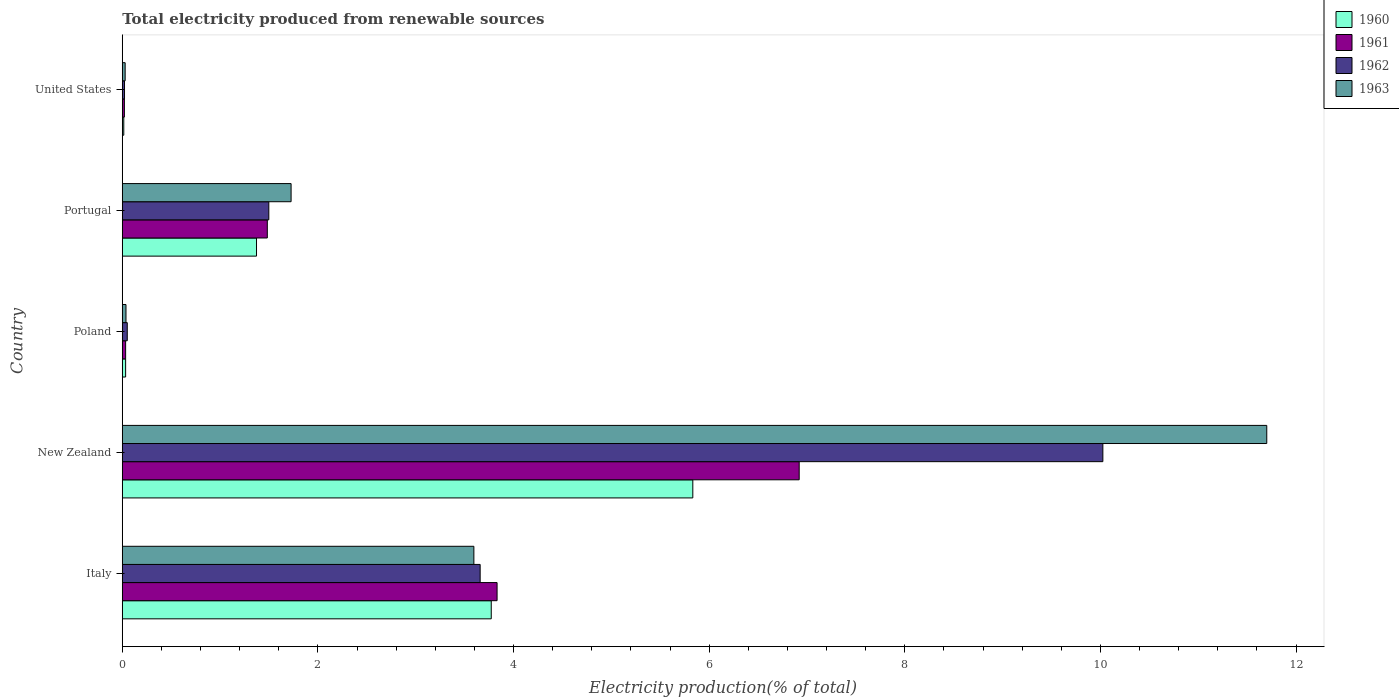How many groups of bars are there?
Provide a succinct answer. 5. Are the number of bars on each tick of the Y-axis equal?
Provide a succinct answer. Yes. How many bars are there on the 1st tick from the top?
Your answer should be compact. 4. How many bars are there on the 2nd tick from the bottom?
Ensure brevity in your answer.  4. What is the label of the 2nd group of bars from the top?
Ensure brevity in your answer.  Portugal. What is the total electricity produced in 1960 in Portugal?
Provide a succinct answer. 1.37. Across all countries, what is the maximum total electricity produced in 1960?
Make the answer very short. 5.83. Across all countries, what is the minimum total electricity produced in 1963?
Your answer should be compact. 0.03. In which country was the total electricity produced in 1960 maximum?
Provide a succinct answer. New Zealand. What is the total total electricity produced in 1963 in the graph?
Keep it short and to the point. 17.09. What is the difference between the total electricity produced in 1962 in Italy and that in New Zealand?
Your response must be concise. -6.37. What is the difference between the total electricity produced in 1961 in United States and the total electricity produced in 1960 in New Zealand?
Provide a short and direct response. -5.81. What is the average total electricity produced in 1962 per country?
Your answer should be very brief. 3.05. What is the difference between the total electricity produced in 1961 and total electricity produced in 1960 in Portugal?
Offer a very short reply. 0.11. What is the ratio of the total electricity produced in 1960 in Portugal to that in United States?
Your answer should be very brief. 89.96. What is the difference between the highest and the second highest total electricity produced in 1960?
Make the answer very short. 2.06. What is the difference between the highest and the lowest total electricity produced in 1963?
Offer a very short reply. 11.67. In how many countries, is the total electricity produced in 1962 greater than the average total electricity produced in 1962 taken over all countries?
Offer a very short reply. 2. Is the sum of the total electricity produced in 1962 in Italy and United States greater than the maximum total electricity produced in 1963 across all countries?
Offer a terse response. No. Is it the case that in every country, the sum of the total electricity produced in 1963 and total electricity produced in 1960 is greater than the sum of total electricity produced in 1962 and total electricity produced in 1961?
Provide a succinct answer. No. What does the 4th bar from the top in Italy represents?
Your response must be concise. 1960. What does the 1st bar from the bottom in Italy represents?
Your response must be concise. 1960. How many bars are there?
Your response must be concise. 20. Are all the bars in the graph horizontal?
Make the answer very short. Yes. Are the values on the major ticks of X-axis written in scientific E-notation?
Your response must be concise. No. Does the graph contain any zero values?
Offer a terse response. No. How are the legend labels stacked?
Your response must be concise. Vertical. What is the title of the graph?
Provide a short and direct response. Total electricity produced from renewable sources. Does "1961" appear as one of the legend labels in the graph?
Keep it short and to the point. Yes. What is the label or title of the Y-axis?
Ensure brevity in your answer.  Country. What is the Electricity production(% of total) of 1960 in Italy?
Provide a succinct answer. 3.77. What is the Electricity production(% of total) of 1961 in Italy?
Give a very brief answer. 3.83. What is the Electricity production(% of total) in 1962 in Italy?
Your response must be concise. 3.66. What is the Electricity production(% of total) in 1963 in Italy?
Ensure brevity in your answer.  3.59. What is the Electricity production(% of total) in 1960 in New Zealand?
Keep it short and to the point. 5.83. What is the Electricity production(% of total) in 1961 in New Zealand?
Keep it short and to the point. 6.92. What is the Electricity production(% of total) of 1962 in New Zealand?
Your answer should be very brief. 10.02. What is the Electricity production(% of total) of 1963 in New Zealand?
Ensure brevity in your answer.  11.7. What is the Electricity production(% of total) in 1960 in Poland?
Provide a succinct answer. 0.03. What is the Electricity production(% of total) in 1961 in Poland?
Your answer should be very brief. 0.03. What is the Electricity production(% of total) of 1962 in Poland?
Offer a very short reply. 0.05. What is the Electricity production(% of total) of 1963 in Poland?
Your answer should be very brief. 0.04. What is the Electricity production(% of total) of 1960 in Portugal?
Offer a very short reply. 1.37. What is the Electricity production(% of total) of 1961 in Portugal?
Ensure brevity in your answer.  1.48. What is the Electricity production(% of total) in 1962 in Portugal?
Provide a short and direct response. 1.5. What is the Electricity production(% of total) in 1963 in Portugal?
Offer a terse response. 1.73. What is the Electricity production(% of total) in 1960 in United States?
Ensure brevity in your answer.  0.02. What is the Electricity production(% of total) in 1961 in United States?
Provide a short and direct response. 0.02. What is the Electricity production(% of total) in 1962 in United States?
Provide a short and direct response. 0.02. What is the Electricity production(% of total) of 1963 in United States?
Ensure brevity in your answer.  0.03. Across all countries, what is the maximum Electricity production(% of total) of 1960?
Provide a succinct answer. 5.83. Across all countries, what is the maximum Electricity production(% of total) in 1961?
Offer a terse response. 6.92. Across all countries, what is the maximum Electricity production(% of total) in 1962?
Make the answer very short. 10.02. Across all countries, what is the maximum Electricity production(% of total) of 1963?
Keep it short and to the point. 11.7. Across all countries, what is the minimum Electricity production(% of total) in 1960?
Ensure brevity in your answer.  0.02. Across all countries, what is the minimum Electricity production(% of total) in 1961?
Your response must be concise. 0.02. Across all countries, what is the minimum Electricity production(% of total) in 1962?
Keep it short and to the point. 0.02. Across all countries, what is the minimum Electricity production(% of total) of 1963?
Provide a short and direct response. 0.03. What is the total Electricity production(% of total) of 1960 in the graph?
Provide a succinct answer. 11.03. What is the total Electricity production(% of total) in 1961 in the graph?
Your answer should be very brief. 12.29. What is the total Electricity production(% of total) of 1962 in the graph?
Offer a very short reply. 15.25. What is the total Electricity production(% of total) in 1963 in the graph?
Offer a very short reply. 17.09. What is the difference between the Electricity production(% of total) of 1960 in Italy and that in New Zealand?
Provide a short and direct response. -2.06. What is the difference between the Electricity production(% of total) in 1961 in Italy and that in New Zealand?
Offer a very short reply. -3.09. What is the difference between the Electricity production(% of total) in 1962 in Italy and that in New Zealand?
Provide a succinct answer. -6.37. What is the difference between the Electricity production(% of total) in 1963 in Italy and that in New Zealand?
Your response must be concise. -8.11. What is the difference between the Electricity production(% of total) in 1960 in Italy and that in Poland?
Your answer should be very brief. 3.74. What is the difference between the Electricity production(% of total) in 1961 in Italy and that in Poland?
Provide a short and direct response. 3.8. What is the difference between the Electricity production(% of total) of 1962 in Italy and that in Poland?
Your answer should be compact. 3.61. What is the difference between the Electricity production(% of total) in 1963 in Italy and that in Poland?
Your response must be concise. 3.56. What is the difference between the Electricity production(% of total) of 1960 in Italy and that in Portugal?
Make the answer very short. 2.4. What is the difference between the Electricity production(% of total) of 1961 in Italy and that in Portugal?
Give a very brief answer. 2.35. What is the difference between the Electricity production(% of total) of 1962 in Italy and that in Portugal?
Your answer should be very brief. 2.16. What is the difference between the Electricity production(% of total) of 1963 in Italy and that in Portugal?
Give a very brief answer. 1.87. What is the difference between the Electricity production(% of total) in 1960 in Italy and that in United States?
Offer a terse response. 3.76. What is the difference between the Electricity production(% of total) of 1961 in Italy and that in United States?
Make the answer very short. 3.81. What is the difference between the Electricity production(% of total) in 1962 in Italy and that in United States?
Offer a terse response. 3.64. What is the difference between the Electricity production(% of total) in 1963 in Italy and that in United States?
Ensure brevity in your answer.  3.56. What is the difference between the Electricity production(% of total) of 1960 in New Zealand and that in Poland?
Your answer should be very brief. 5.8. What is the difference between the Electricity production(% of total) of 1961 in New Zealand and that in Poland?
Offer a terse response. 6.89. What is the difference between the Electricity production(% of total) of 1962 in New Zealand and that in Poland?
Offer a terse response. 9.97. What is the difference between the Electricity production(% of total) of 1963 in New Zealand and that in Poland?
Offer a terse response. 11.66. What is the difference between the Electricity production(% of total) in 1960 in New Zealand and that in Portugal?
Keep it short and to the point. 4.46. What is the difference between the Electricity production(% of total) of 1961 in New Zealand and that in Portugal?
Your answer should be compact. 5.44. What is the difference between the Electricity production(% of total) of 1962 in New Zealand and that in Portugal?
Provide a succinct answer. 8.53. What is the difference between the Electricity production(% of total) of 1963 in New Zealand and that in Portugal?
Ensure brevity in your answer.  9.97. What is the difference between the Electricity production(% of total) of 1960 in New Zealand and that in United States?
Keep it short and to the point. 5.82. What is the difference between the Electricity production(% of total) of 1961 in New Zealand and that in United States?
Offer a very short reply. 6.9. What is the difference between the Electricity production(% of total) in 1962 in New Zealand and that in United States?
Provide a short and direct response. 10. What is the difference between the Electricity production(% of total) of 1963 in New Zealand and that in United States?
Offer a very short reply. 11.67. What is the difference between the Electricity production(% of total) of 1960 in Poland and that in Portugal?
Keep it short and to the point. -1.34. What is the difference between the Electricity production(% of total) of 1961 in Poland and that in Portugal?
Provide a succinct answer. -1.45. What is the difference between the Electricity production(% of total) in 1962 in Poland and that in Portugal?
Make the answer very short. -1.45. What is the difference between the Electricity production(% of total) of 1963 in Poland and that in Portugal?
Ensure brevity in your answer.  -1.69. What is the difference between the Electricity production(% of total) in 1960 in Poland and that in United States?
Your answer should be very brief. 0.02. What is the difference between the Electricity production(% of total) in 1961 in Poland and that in United States?
Ensure brevity in your answer.  0.01. What is the difference between the Electricity production(% of total) in 1962 in Poland and that in United States?
Offer a terse response. 0.03. What is the difference between the Electricity production(% of total) in 1963 in Poland and that in United States?
Ensure brevity in your answer.  0.01. What is the difference between the Electricity production(% of total) of 1960 in Portugal and that in United States?
Your answer should be very brief. 1.36. What is the difference between the Electricity production(% of total) of 1961 in Portugal and that in United States?
Give a very brief answer. 1.46. What is the difference between the Electricity production(% of total) in 1962 in Portugal and that in United States?
Provide a succinct answer. 1.48. What is the difference between the Electricity production(% of total) of 1963 in Portugal and that in United States?
Your answer should be very brief. 1.7. What is the difference between the Electricity production(% of total) in 1960 in Italy and the Electricity production(% of total) in 1961 in New Zealand?
Provide a succinct answer. -3.15. What is the difference between the Electricity production(% of total) of 1960 in Italy and the Electricity production(% of total) of 1962 in New Zealand?
Provide a short and direct response. -6.25. What is the difference between the Electricity production(% of total) of 1960 in Italy and the Electricity production(% of total) of 1963 in New Zealand?
Provide a short and direct response. -7.93. What is the difference between the Electricity production(% of total) of 1961 in Italy and the Electricity production(% of total) of 1962 in New Zealand?
Offer a terse response. -6.19. What is the difference between the Electricity production(% of total) of 1961 in Italy and the Electricity production(% of total) of 1963 in New Zealand?
Ensure brevity in your answer.  -7.87. What is the difference between the Electricity production(% of total) of 1962 in Italy and the Electricity production(% of total) of 1963 in New Zealand?
Offer a terse response. -8.04. What is the difference between the Electricity production(% of total) in 1960 in Italy and the Electricity production(% of total) in 1961 in Poland?
Make the answer very short. 3.74. What is the difference between the Electricity production(% of total) of 1960 in Italy and the Electricity production(% of total) of 1962 in Poland?
Provide a succinct answer. 3.72. What is the difference between the Electricity production(% of total) in 1960 in Italy and the Electricity production(% of total) in 1963 in Poland?
Ensure brevity in your answer.  3.73. What is the difference between the Electricity production(% of total) of 1961 in Italy and the Electricity production(% of total) of 1962 in Poland?
Give a very brief answer. 3.78. What is the difference between the Electricity production(% of total) in 1961 in Italy and the Electricity production(% of total) in 1963 in Poland?
Your response must be concise. 3.79. What is the difference between the Electricity production(% of total) in 1962 in Italy and the Electricity production(% of total) in 1963 in Poland?
Provide a short and direct response. 3.62. What is the difference between the Electricity production(% of total) of 1960 in Italy and the Electricity production(% of total) of 1961 in Portugal?
Ensure brevity in your answer.  2.29. What is the difference between the Electricity production(% of total) of 1960 in Italy and the Electricity production(% of total) of 1962 in Portugal?
Your answer should be compact. 2.27. What is the difference between the Electricity production(% of total) in 1960 in Italy and the Electricity production(% of total) in 1963 in Portugal?
Make the answer very short. 2.05. What is the difference between the Electricity production(% of total) in 1961 in Italy and the Electricity production(% of total) in 1962 in Portugal?
Your answer should be very brief. 2.33. What is the difference between the Electricity production(% of total) in 1961 in Italy and the Electricity production(% of total) in 1963 in Portugal?
Provide a short and direct response. 2.11. What is the difference between the Electricity production(% of total) in 1962 in Italy and the Electricity production(% of total) in 1963 in Portugal?
Provide a succinct answer. 1.93. What is the difference between the Electricity production(% of total) of 1960 in Italy and the Electricity production(% of total) of 1961 in United States?
Provide a succinct answer. 3.75. What is the difference between the Electricity production(% of total) of 1960 in Italy and the Electricity production(% of total) of 1962 in United States?
Your answer should be compact. 3.75. What is the difference between the Electricity production(% of total) of 1960 in Italy and the Electricity production(% of total) of 1963 in United States?
Your answer should be compact. 3.74. What is the difference between the Electricity production(% of total) of 1961 in Italy and the Electricity production(% of total) of 1962 in United States?
Offer a terse response. 3.81. What is the difference between the Electricity production(% of total) of 1961 in Italy and the Electricity production(% of total) of 1963 in United States?
Provide a short and direct response. 3.8. What is the difference between the Electricity production(% of total) in 1962 in Italy and the Electricity production(% of total) in 1963 in United States?
Your answer should be compact. 3.63. What is the difference between the Electricity production(% of total) in 1960 in New Zealand and the Electricity production(% of total) in 1961 in Poland?
Keep it short and to the point. 5.8. What is the difference between the Electricity production(% of total) in 1960 in New Zealand and the Electricity production(% of total) in 1962 in Poland?
Keep it short and to the point. 5.78. What is the difference between the Electricity production(% of total) of 1960 in New Zealand and the Electricity production(% of total) of 1963 in Poland?
Offer a very short reply. 5.79. What is the difference between the Electricity production(% of total) of 1961 in New Zealand and the Electricity production(% of total) of 1962 in Poland?
Provide a short and direct response. 6.87. What is the difference between the Electricity production(% of total) of 1961 in New Zealand and the Electricity production(% of total) of 1963 in Poland?
Your answer should be compact. 6.88. What is the difference between the Electricity production(% of total) of 1962 in New Zealand and the Electricity production(% of total) of 1963 in Poland?
Make the answer very short. 9.99. What is the difference between the Electricity production(% of total) of 1960 in New Zealand and the Electricity production(% of total) of 1961 in Portugal?
Provide a short and direct response. 4.35. What is the difference between the Electricity production(% of total) of 1960 in New Zealand and the Electricity production(% of total) of 1962 in Portugal?
Your response must be concise. 4.33. What is the difference between the Electricity production(% of total) of 1960 in New Zealand and the Electricity production(% of total) of 1963 in Portugal?
Offer a very short reply. 4.11. What is the difference between the Electricity production(% of total) in 1961 in New Zealand and the Electricity production(% of total) in 1962 in Portugal?
Your answer should be very brief. 5.42. What is the difference between the Electricity production(% of total) in 1961 in New Zealand and the Electricity production(% of total) in 1963 in Portugal?
Your answer should be compact. 5.19. What is the difference between the Electricity production(% of total) of 1962 in New Zealand and the Electricity production(% of total) of 1963 in Portugal?
Provide a short and direct response. 8.3. What is the difference between the Electricity production(% of total) in 1960 in New Zealand and the Electricity production(% of total) in 1961 in United States?
Give a very brief answer. 5.81. What is the difference between the Electricity production(% of total) of 1960 in New Zealand and the Electricity production(% of total) of 1962 in United States?
Your answer should be very brief. 5.81. What is the difference between the Electricity production(% of total) of 1960 in New Zealand and the Electricity production(% of total) of 1963 in United States?
Ensure brevity in your answer.  5.8. What is the difference between the Electricity production(% of total) of 1961 in New Zealand and the Electricity production(% of total) of 1962 in United States?
Your answer should be compact. 6.9. What is the difference between the Electricity production(% of total) of 1961 in New Zealand and the Electricity production(% of total) of 1963 in United States?
Offer a terse response. 6.89. What is the difference between the Electricity production(% of total) in 1962 in New Zealand and the Electricity production(% of total) in 1963 in United States?
Offer a terse response. 10. What is the difference between the Electricity production(% of total) in 1960 in Poland and the Electricity production(% of total) in 1961 in Portugal?
Offer a terse response. -1.45. What is the difference between the Electricity production(% of total) of 1960 in Poland and the Electricity production(% of total) of 1962 in Portugal?
Your answer should be very brief. -1.46. What is the difference between the Electricity production(% of total) in 1960 in Poland and the Electricity production(% of total) in 1963 in Portugal?
Ensure brevity in your answer.  -1.69. What is the difference between the Electricity production(% of total) of 1961 in Poland and the Electricity production(% of total) of 1962 in Portugal?
Provide a short and direct response. -1.46. What is the difference between the Electricity production(% of total) of 1961 in Poland and the Electricity production(% of total) of 1963 in Portugal?
Your answer should be very brief. -1.69. What is the difference between the Electricity production(% of total) in 1962 in Poland and the Electricity production(% of total) in 1963 in Portugal?
Keep it short and to the point. -1.67. What is the difference between the Electricity production(% of total) in 1960 in Poland and the Electricity production(% of total) in 1961 in United States?
Your response must be concise. 0.01. What is the difference between the Electricity production(% of total) of 1960 in Poland and the Electricity production(% of total) of 1962 in United States?
Keep it short and to the point. 0.01. What is the difference between the Electricity production(% of total) in 1960 in Poland and the Electricity production(% of total) in 1963 in United States?
Keep it short and to the point. 0. What is the difference between the Electricity production(% of total) of 1961 in Poland and the Electricity production(% of total) of 1962 in United States?
Give a very brief answer. 0.01. What is the difference between the Electricity production(% of total) in 1961 in Poland and the Electricity production(% of total) in 1963 in United States?
Offer a very short reply. 0. What is the difference between the Electricity production(% of total) in 1962 in Poland and the Electricity production(% of total) in 1963 in United States?
Make the answer very short. 0.02. What is the difference between the Electricity production(% of total) in 1960 in Portugal and the Electricity production(% of total) in 1961 in United States?
Provide a short and direct response. 1.35. What is the difference between the Electricity production(% of total) in 1960 in Portugal and the Electricity production(% of total) in 1962 in United States?
Offer a very short reply. 1.35. What is the difference between the Electricity production(% of total) of 1960 in Portugal and the Electricity production(% of total) of 1963 in United States?
Make the answer very short. 1.34. What is the difference between the Electricity production(% of total) in 1961 in Portugal and the Electricity production(% of total) in 1962 in United States?
Your response must be concise. 1.46. What is the difference between the Electricity production(% of total) of 1961 in Portugal and the Electricity production(% of total) of 1963 in United States?
Offer a terse response. 1.45. What is the difference between the Electricity production(% of total) in 1962 in Portugal and the Electricity production(% of total) in 1963 in United States?
Your response must be concise. 1.47. What is the average Electricity production(% of total) of 1960 per country?
Make the answer very short. 2.21. What is the average Electricity production(% of total) of 1961 per country?
Offer a terse response. 2.46. What is the average Electricity production(% of total) of 1962 per country?
Your answer should be compact. 3.05. What is the average Electricity production(% of total) in 1963 per country?
Provide a short and direct response. 3.42. What is the difference between the Electricity production(% of total) in 1960 and Electricity production(% of total) in 1961 in Italy?
Keep it short and to the point. -0.06. What is the difference between the Electricity production(% of total) in 1960 and Electricity production(% of total) in 1962 in Italy?
Your answer should be very brief. 0.11. What is the difference between the Electricity production(% of total) in 1960 and Electricity production(% of total) in 1963 in Italy?
Provide a short and direct response. 0.18. What is the difference between the Electricity production(% of total) in 1961 and Electricity production(% of total) in 1962 in Italy?
Give a very brief answer. 0.17. What is the difference between the Electricity production(% of total) of 1961 and Electricity production(% of total) of 1963 in Italy?
Your response must be concise. 0.24. What is the difference between the Electricity production(% of total) of 1962 and Electricity production(% of total) of 1963 in Italy?
Keep it short and to the point. 0.06. What is the difference between the Electricity production(% of total) of 1960 and Electricity production(% of total) of 1961 in New Zealand?
Offer a terse response. -1.09. What is the difference between the Electricity production(% of total) in 1960 and Electricity production(% of total) in 1962 in New Zealand?
Provide a short and direct response. -4.19. What is the difference between the Electricity production(% of total) in 1960 and Electricity production(% of total) in 1963 in New Zealand?
Your answer should be compact. -5.87. What is the difference between the Electricity production(% of total) in 1961 and Electricity production(% of total) in 1962 in New Zealand?
Your answer should be compact. -3.1. What is the difference between the Electricity production(% of total) in 1961 and Electricity production(% of total) in 1963 in New Zealand?
Make the answer very short. -4.78. What is the difference between the Electricity production(% of total) of 1962 and Electricity production(% of total) of 1963 in New Zealand?
Your response must be concise. -1.68. What is the difference between the Electricity production(% of total) of 1960 and Electricity production(% of total) of 1962 in Poland?
Provide a succinct answer. -0.02. What is the difference between the Electricity production(% of total) of 1960 and Electricity production(% of total) of 1963 in Poland?
Your response must be concise. -0. What is the difference between the Electricity production(% of total) in 1961 and Electricity production(% of total) in 1962 in Poland?
Keep it short and to the point. -0.02. What is the difference between the Electricity production(% of total) of 1961 and Electricity production(% of total) of 1963 in Poland?
Offer a very short reply. -0. What is the difference between the Electricity production(% of total) in 1962 and Electricity production(% of total) in 1963 in Poland?
Ensure brevity in your answer.  0.01. What is the difference between the Electricity production(% of total) of 1960 and Electricity production(% of total) of 1961 in Portugal?
Keep it short and to the point. -0.11. What is the difference between the Electricity production(% of total) of 1960 and Electricity production(% of total) of 1962 in Portugal?
Provide a short and direct response. -0.13. What is the difference between the Electricity production(% of total) of 1960 and Electricity production(% of total) of 1963 in Portugal?
Provide a short and direct response. -0.35. What is the difference between the Electricity production(% of total) of 1961 and Electricity production(% of total) of 1962 in Portugal?
Your answer should be compact. -0.02. What is the difference between the Electricity production(% of total) in 1961 and Electricity production(% of total) in 1963 in Portugal?
Your answer should be compact. -0.24. What is the difference between the Electricity production(% of total) in 1962 and Electricity production(% of total) in 1963 in Portugal?
Your response must be concise. -0.23. What is the difference between the Electricity production(% of total) of 1960 and Electricity production(% of total) of 1961 in United States?
Make the answer very short. -0.01. What is the difference between the Electricity production(% of total) in 1960 and Electricity production(% of total) in 1962 in United States?
Offer a very short reply. -0.01. What is the difference between the Electricity production(% of total) of 1960 and Electricity production(% of total) of 1963 in United States?
Your answer should be compact. -0.01. What is the difference between the Electricity production(% of total) in 1961 and Electricity production(% of total) in 1962 in United States?
Your answer should be very brief. -0. What is the difference between the Electricity production(% of total) of 1961 and Electricity production(% of total) of 1963 in United States?
Your answer should be very brief. -0.01. What is the difference between the Electricity production(% of total) in 1962 and Electricity production(% of total) in 1963 in United States?
Offer a very short reply. -0.01. What is the ratio of the Electricity production(% of total) of 1960 in Italy to that in New Zealand?
Offer a very short reply. 0.65. What is the ratio of the Electricity production(% of total) in 1961 in Italy to that in New Zealand?
Offer a terse response. 0.55. What is the ratio of the Electricity production(% of total) of 1962 in Italy to that in New Zealand?
Provide a succinct answer. 0.36. What is the ratio of the Electricity production(% of total) of 1963 in Italy to that in New Zealand?
Make the answer very short. 0.31. What is the ratio of the Electricity production(% of total) of 1960 in Italy to that in Poland?
Provide a succinct answer. 110.45. What is the ratio of the Electricity production(% of total) of 1961 in Italy to that in Poland?
Provide a succinct answer. 112.3. What is the ratio of the Electricity production(% of total) of 1962 in Italy to that in Poland?
Your response must be concise. 71.88. What is the ratio of the Electricity production(% of total) in 1963 in Italy to that in Poland?
Offer a terse response. 94.84. What is the ratio of the Electricity production(% of total) of 1960 in Italy to that in Portugal?
Keep it short and to the point. 2.75. What is the ratio of the Electricity production(% of total) in 1961 in Italy to that in Portugal?
Provide a succinct answer. 2.58. What is the ratio of the Electricity production(% of total) in 1962 in Italy to that in Portugal?
Your answer should be compact. 2.44. What is the ratio of the Electricity production(% of total) of 1963 in Italy to that in Portugal?
Offer a very short reply. 2.08. What is the ratio of the Electricity production(% of total) in 1960 in Italy to that in United States?
Your answer should be very brief. 247.25. What is the ratio of the Electricity production(% of total) in 1961 in Italy to that in United States?
Your response must be concise. 177.87. What is the ratio of the Electricity production(% of total) in 1962 in Italy to that in United States?
Your response must be concise. 160.56. What is the ratio of the Electricity production(% of total) in 1963 in Italy to that in United States?
Provide a short and direct response. 122.12. What is the ratio of the Electricity production(% of total) of 1960 in New Zealand to that in Poland?
Ensure brevity in your answer.  170.79. What is the ratio of the Electricity production(% of total) in 1961 in New Zealand to that in Poland?
Give a very brief answer. 202.83. What is the ratio of the Electricity production(% of total) in 1962 in New Zealand to that in Poland?
Give a very brief answer. 196.95. What is the ratio of the Electricity production(% of total) of 1963 in New Zealand to that in Poland?
Your answer should be very brief. 308.73. What is the ratio of the Electricity production(% of total) of 1960 in New Zealand to that in Portugal?
Your response must be concise. 4.25. What is the ratio of the Electricity production(% of total) of 1961 in New Zealand to that in Portugal?
Your response must be concise. 4.67. What is the ratio of the Electricity production(% of total) in 1962 in New Zealand to that in Portugal?
Your response must be concise. 6.69. What is the ratio of the Electricity production(% of total) of 1963 in New Zealand to that in Portugal?
Keep it short and to the point. 6.78. What is the ratio of the Electricity production(% of total) of 1960 in New Zealand to that in United States?
Ensure brevity in your answer.  382.31. What is the ratio of the Electricity production(% of total) in 1961 in New Zealand to that in United States?
Give a very brief answer. 321.25. What is the ratio of the Electricity production(% of total) of 1962 in New Zealand to that in United States?
Your answer should be compact. 439.93. What is the ratio of the Electricity production(% of total) in 1963 in New Zealand to that in United States?
Ensure brevity in your answer.  397.5. What is the ratio of the Electricity production(% of total) in 1960 in Poland to that in Portugal?
Provide a short and direct response. 0.02. What is the ratio of the Electricity production(% of total) of 1961 in Poland to that in Portugal?
Your answer should be compact. 0.02. What is the ratio of the Electricity production(% of total) in 1962 in Poland to that in Portugal?
Your answer should be compact. 0.03. What is the ratio of the Electricity production(% of total) of 1963 in Poland to that in Portugal?
Ensure brevity in your answer.  0.02. What is the ratio of the Electricity production(% of total) of 1960 in Poland to that in United States?
Keep it short and to the point. 2.24. What is the ratio of the Electricity production(% of total) in 1961 in Poland to that in United States?
Make the answer very short. 1.58. What is the ratio of the Electricity production(% of total) in 1962 in Poland to that in United States?
Your answer should be compact. 2.23. What is the ratio of the Electricity production(% of total) in 1963 in Poland to that in United States?
Give a very brief answer. 1.29. What is the ratio of the Electricity production(% of total) of 1960 in Portugal to that in United States?
Offer a very short reply. 89.96. What is the ratio of the Electricity production(% of total) in 1961 in Portugal to that in United States?
Make the answer very short. 68.83. What is the ratio of the Electricity production(% of total) in 1962 in Portugal to that in United States?
Ensure brevity in your answer.  65.74. What is the ratio of the Electricity production(% of total) of 1963 in Portugal to that in United States?
Provide a succinct answer. 58.63. What is the difference between the highest and the second highest Electricity production(% of total) of 1960?
Make the answer very short. 2.06. What is the difference between the highest and the second highest Electricity production(% of total) of 1961?
Your answer should be compact. 3.09. What is the difference between the highest and the second highest Electricity production(% of total) of 1962?
Keep it short and to the point. 6.37. What is the difference between the highest and the second highest Electricity production(% of total) of 1963?
Make the answer very short. 8.11. What is the difference between the highest and the lowest Electricity production(% of total) in 1960?
Offer a terse response. 5.82. What is the difference between the highest and the lowest Electricity production(% of total) in 1961?
Your answer should be compact. 6.9. What is the difference between the highest and the lowest Electricity production(% of total) of 1962?
Your answer should be very brief. 10. What is the difference between the highest and the lowest Electricity production(% of total) in 1963?
Keep it short and to the point. 11.67. 